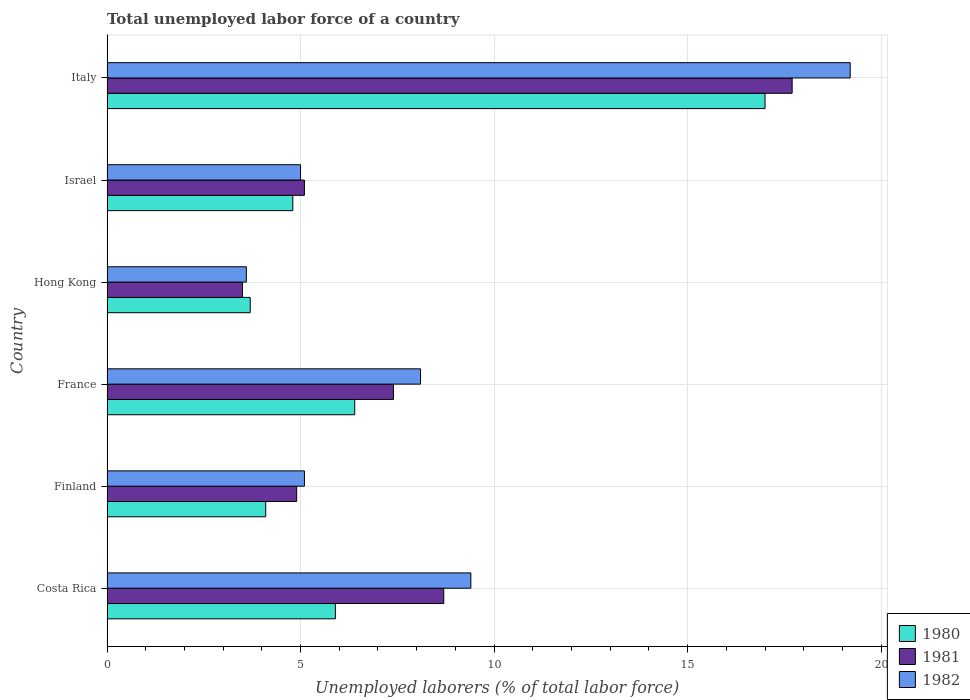How many different coloured bars are there?
Ensure brevity in your answer.  3. How many groups of bars are there?
Keep it short and to the point. 6. Are the number of bars per tick equal to the number of legend labels?
Your answer should be very brief. Yes. Are the number of bars on each tick of the Y-axis equal?
Keep it short and to the point. Yes. How many bars are there on the 4th tick from the top?
Offer a terse response. 3. How many bars are there on the 1st tick from the bottom?
Offer a very short reply. 3. What is the label of the 5th group of bars from the top?
Make the answer very short. Finland. In how many cases, is the number of bars for a given country not equal to the number of legend labels?
Make the answer very short. 0. What is the total unemployed labor force in 1981 in France?
Ensure brevity in your answer.  7.4. Across all countries, what is the maximum total unemployed labor force in 1980?
Your answer should be compact. 17. Across all countries, what is the minimum total unemployed labor force in 1981?
Your response must be concise. 3.5. In which country was the total unemployed labor force in 1980 maximum?
Give a very brief answer. Italy. In which country was the total unemployed labor force in 1982 minimum?
Provide a succinct answer. Hong Kong. What is the total total unemployed labor force in 1981 in the graph?
Ensure brevity in your answer.  47.3. What is the difference between the total unemployed labor force in 1982 in Hong Kong and that in Italy?
Provide a succinct answer. -15.6. What is the difference between the total unemployed labor force in 1981 in Italy and the total unemployed labor force in 1982 in Hong Kong?
Offer a very short reply. 14.1. What is the average total unemployed labor force in 1982 per country?
Give a very brief answer. 8.4. What is the difference between the total unemployed labor force in 1980 and total unemployed labor force in 1982 in Italy?
Ensure brevity in your answer.  -2.2. What is the ratio of the total unemployed labor force in 1980 in France to that in Hong Kong?
Give a very brief answer. 1.73. What is the difference between the highest and the second highest total unemployed labor force in 1980?
Provide a succinct answer. 10.6. What is the difference between the highest and the lowest total unemployed labor force in 1981?
Your answer should be very brief. 14.2. How many bars are there?
Make the answer very short. 18. Are all the bars in the graph horizontal?
Ensure brevity in your answer.  Yes. Does the graph contain grids?
Offer a terse response. Yes. How many legend labels are there?
Keep it short and to the point. 3. What is the title of the graph?
Give a very brief answer. Total unemployed labor force of a country. What is the label or title of the X-axis?
Your answer should be very brief. Unemployed laborers (% of total labor force). What is the label or title of the Y-axis?
Your response must be concise. Country. What is the Unemployed laborers (% of total labor force) in 1980 in Costa Rica?
Make the answer very short. 5.9. What is the Unemployed laborers (% of total labor force) of 1981 in Costa Rica?
Your answer should be compact. 8.7. What is the Unemployed laborers (% of total labor force) of 1982 in Costa Rica?
Offer a very short reply. 9.4. What is the Unemployed laborers (% of total labor force) of 1980 in Finland?
Provide a succinct answer. 4.1. What is the Unemployed laborers (% of total labor force) of 1981 in Finland?
Make the answer very short. 4.9. What is the Unemployed laborers (% of total labor force) of 1982 in Finland?
Ensure brevity in your answer.  5.1. What is the Unemployed laborers (% of total labor force) in 1980 in France?
Ensure brevity in your answer.  6.4. What is the Unemployed laborers (% of total labor force) of 1981 in France?
Your response must be concise. 7.4. What is the Unemployed laborers (% of total labor force) in 1982 in France?
Provide a succinct answer. 8.1. What is the Unemployed laborers (% of total labor force) in 1980 in Hong Kong?
Provide a short and direct response. 3.7. What is the Unemployed laborers (% of total labor force) of 1981 in Hong Kong?
Provide a short and direct response. 3.5. What is the Unemployed laborers (% of total labor force) of 1982 in Hong Kong?
Provide a succinct answer. 3.6. What is the Unemployed laborers (% of total labor force) in 1980 in Israel?
Your answer should be very brief. 4.8. What is the Unemployed laborers (% of total labor force) in 1981 in Israel?
Your response must be concise. 5.1. What is the Unemployed laborers (% of total labor force) in 1980 in Italy?
Your response must be concise. 17. What is the Unemployed laborers (% of total labor force) of 1981 in Italy?
Make the answer very short. 17.7. What is the Unemployed laborers (% of total labor force) in 1982 in Italy?
Provide a short and direct response. 19.2. Across all countries, what is the maximum Unemployed laborers (% of total labor force) in 1980?
Keep it short and to the point. 17. Across all countries, what is the maximum Unemployed laborers (% of total labor force) of 1981?
Give a very brief answer. 17.7. Across all countries, what is the maximum Unemployed laborers (% of total labor force) of 1982?
Your answer should be compact. 19.2. Across all countries, what is the minimum Unemployed laborers (% of total labor force) in 1980?
Keep it short and to the point. 3.7. Across all countries, what is the minimum Unemployed laborers (% of total labor force) of 1981?
Keep it short and to the point. 3.5. Across all countries, what is the minimum Unemployed laborers (% of total labor force) in 1982?
Provide a short and direct response. 3.6. What is the total Unemployed laborers (% of total labor force) of 1980 in the graph?
Your answer should be compact. 41.9. What is the total Unemployed laborers (% of total labor force) in 1981 in the graph?
Offer a very short reply. 47.3. What is the total Unemployed laborers (% of total labor force) in 1982 in the graph?
Keep it short and to the point. 50.4. What is the difference between the Unemployed laborers (% of total labor force) of 1982 in Costa Rica and that in Finland?
Offer a terse response. 4.3. What is the difference between the Unemployed laborers (% of total labor force) of 1980 in Costa Rica and that in Hong Kong?
Provide a short and direct response. 2.2. What is the difference between the Unemployed laborers (% of total labor force) in 1982 in Costa Rica and that in Hong Kong?
Offer a very short reply. 5.8. What is the difference between the Unemployed laborers (% of total labor force) in 1982 in Costa Rica and that in Israel?
Offer a terse response. 4.4. What is the difference between the Unemployed laborers (% of total labor force) of 1980 in Costa Rica and that in Italy?
Give a very brief answer. -11.1. What is the difference between the Unemployed laborers (% of total labor force) of 1982 in Costa Rica and that in Italy?
Give a very brief answer. -9.8. What is the difference between the Unemployed laborers (% of total labor force) in 1980 in Finland and that in France?
Give a very brief answer. -2.3. What is the difference between the Unemployed laborers (% of total labor force) of 1981 in Finland and that in France?
Offer a very short reply. -2.5. What is the difference between the Unemployed laborers (% of total labor force) of 1982 in Finland and that in France?
Give a very brief answer. -3. What is the difference between the Unemployed laborers (% of total labor force) in 1982 in Finland and that in Hong Kong?
Offer a very short reply. 1.5. What is the difference between the Unemployed laborers (% of total labor force) in 1981 in Finland and that in Israel?
Your answer should be very brief. -0.2. What is the difference between the Unemployed laborers (% of total labor force) of 1982 in Finland and that in Israel?
Your response must be concise. 0.1. What is the difference between the Unemployed laborers (% of total labor force) of 1980 in Finland and that in Italy?
Offer a terse response. -12.9. What is the difference between the Unemployed laborers (% of total labor force) of 1982 in Finland and that in Italy?
Ensure brevity in your answer.  -14.1. What is the difference between the Unemployed laborers (% of total labor force) in 1980 in France and that in Hong Kong?
Your answer should be very brief. 2.7. What is the difference between the Unemployed laborers (% of total labor force) of 1981 in France and that in Hong Kong?
Offer a very short reply. 3.9. What is the difference between the Unemployed laborers (% of total labor force) of 1982 in France and that in Hong Kong?
Provide a succinct answer. 4.5. What is the difference between the Unemployed laborers (% of total labor force) in 1981 in France and that in Israel?
Give a very brief answer. 2.3. What is the difference between the Unemployed laborers (% of total labor force) in 1980 in France and that in Italy?
Provide a succinct answer. -10.6. What is the difference between the Unemployed laborers (% of total labor force) in 1981 in France and that in Italy?
Your response must be concise. -10.3. What is the difference between the Unemployed laborers (% of total labor force) of 1981 in Hong Kong and that in Israel?
Provide a short and direct response. -1.6. What is the difference between the Unemployed laborers (% of total labor force) of 1981 in Hong Kong and that in Italy?
Give a very brief answer. -14.2. What is the difference between the Unemployed laborers (% of total labor force) in 1982 in Hong Kong and that in Italy?
Make the answer very short. -15.6. What is the difference between the Unemployed laborers (% of total labor force) in 1980 in Costa Rica and the Unemployed laborers (% of total labor force) in 1982 in Finland?
Provide a succinct answer. 0.8. What is the difference between the Unemployed laborers (% of total labor force) of 1980 in Costa Rica and the Unemployed laborers (% of total labor force) of 1981 in France?
Provide a short and direct response. -1.5. What is the difference between the Unemployed laborers (% of total labor force) in 1980 in Costa Rica and the Unemployed laborers (% of total labor force) in 1982 in France?
Your answer should be very brief. -2.2. What is the difference between the Unemployed laborers (% of total labor force) of 1980 in Costa Rica and the Unemployed laborers (% of total labor force) of 1981 in Hong Kong?
Keep it short and to the point. 2.4. What is the difference between the Unemployed laborers (% of total labor force) in 1981 in Costa Rica and the Unemployed laborers (% of total labor force) in 1982 in Hong Kong?
Provide a succinct answer. 5.1. What is the difference between the Unemployed laborers (% of total labor force) of 1980 in Costa Rica and the Unemployed laborers (% of total labor force) of 1981 in Israel?
Keep it short and to the point. 0.8. What is the difference between the Unemployed laborers (% of total labor force) in 1980 in Costa Rica and the Unemployed laborers (% of total labor force) in 1982 in Israel?
Provide a succinct answer. 0.9. What is the difference between the Unemployed laborers (% of total labor force) in 1981 in Costa Rica and the Unemployed laborers (% of total labor force) in 1982 in Israel?
Make the answer very short. 3.7. What is the difference between the Unemployed laborers (% of total labor force) in 1980 in Finland and the Unemployed laborers (% of total labor force) in 1981 in France?
Give a very brief answer. -3.3. What is the difference between the Unemployed laborers (% of total labor force) of 1980 in Finland and the Unemployed laborers (% of total labor force) of 1982 in France?
Keep it short and to the point. -4. What is the difference between the Unemployed laborers (% of total labor force) of 1980 in Finland and the Unemployed laborers (% of total labor force) of 1982 in Hong Kong?
Your response must be concise. 0.5. What is the difference between the Unemployed laborers (% of total labor force) of 1980 in Finland and the Unemployed laborers (% of total labor force) of 1982 in Israel?
Your answer should be very brief. -0.9. What is the difference between the Unemployed laborers (% of total labor force) of 1981 in Finland and the Unemployed laborers (% of total labor force) of 1982 in Israel?
Ensure brevity in your answer.  -0.1. What is the difference between the Unemployed laborers (% of total labor force) of 1980 in Finland and the Unemployed laborers (% of total labor force) of 1981 in Italy?
Ensure brevity in your answer.  -13.6. What is the difference between the Unemployed laborers (% of total labor force) of 1980 in Finland and the Unemployed laborers (% of total labor force) of 1982 in Italy?
Ensure brevity in your answer.  -15.1. What is the difference between the Unemployed laborers (% of total labor force) of 1981 in Finland and the Unemployed laborers (% of total labor force) of 1982 in Italy?
Your answer should be very brief. -14.3. What is the difference between the Unemployed laborers (% of total labor force) of 1980 in France and the Unemployed laborers (% of total labor force) of 1981 in Hong Kong?
Your response must be concise. 2.9. What is the difference between the Unemployed laborers (% of total labor force) in 1981 in France and the Unemployed laborers (% of total labor force) in 1982 in Hong Kong?
Keep it short and to the point. 3.8. What is the difference between the Unemployed laborers (% of total labor force) of 1980 in France and the Unemployed laborers (% of total labor force) of 1982 in Israel?
Ensure brevity in your answer.  1.4. What is the difference between the Unemployed laborers (% of total labor force) of 1981 in France and the Unemployed laborers (% of total labor force) of 1982 in Israel?
Offer a very short reply. 2.4. What is the difference between the Unemployed laborers (% of total labor force) in 1980 in France and the Unemployed laborers (% of total labor force) in 1981 in Italy?
Your response must be concise. -11.3. What is the difference between the Unemployed laborers (% of total labor force) of 1981 in France and the Unemployed laborers (% of total labor force) of 1982 in Italy?
Provide a short and direct response. -11.8. What is the difference between the Unemployed laborers (% of total labor force) in 1980 in Hong Kong and the Unemployed laborers (% of total labor force) in 1981 in Israel?
Make the answer very short. -1.4. What is the difference between the Unemployed laborers (% of total labor force) of 1980 in Hong Kong and the Unemployed laborers (% of total labor force) of 1982 in Israel?
Give a very brief answer. -1.3. What is the difference between the Unemployed laborers (% of total labor force) in 1980 in Hong Kong and the Unemployed laborers (% of total labor force) in 1982 in Italy?
Offer a very short reply. -15.5. What is the difference between the Unemployed laborers (% of total labor force) of 1981 in Hong Kong and the Unemployed laborers (% of total labor force) of 1982 in Italy?
Give a very brief answer. -15.7. What is the difference between the Unemployed laborers (% of total labor force) of 1980 in Israel and the Unemployed laborers (% of total labor force) of 1982 in Italy?
Offer a terse response. -14.4. What is the difference between the Unemployed laborers (% of total labor force) of 1981 in Israel and the Unemployed laborers (% of total labor force) of 1982 in Italy?
Your answer should be very brief. -14.1. What is the average Unemployed laborers (% of total labor force) of 1980 per country?
Your answer should be compact. 6.98. What is the average Unemployed laborers (% of total labor force) of 1981 per country?
Offer a terse response. 7.88. What is the average Unemployed laborers (% of total labor force) in 1982 per country?
Offer a terse response. 8.4. What is the difference between the Unemployed laborers (% of total labor force) in 1980 and Unemployed laborers (% of total labor force) in 1981 in Costa Rica?
Make the answer very short. -2.8. What is the difference between the Unemployed laborers (% of total labor force) in 1980 and Unemployed laborers (% of total labor force) in 1982 in Costa Rica?
Your response must be concise. -3.5. What is the difference between the Unemployed laborers (% of total labor force) in 1980 and Unemployed laborers (% of total labor force) in 1982 in Finland?
Offer a terse response. -1. What is the difference between the Unemployed laborers (% of total labor force) in 1981 and Unemployed laborers (% of total labor force) in 1982 in Finland?
Offer a terse response. -0.2. What is the difference between the Unemployed laborers (% of total labor force) of 1980 and Unemployed laborers (% of total labor force) of 1982 in France?
Ensure brevity in your answer.  -1.7. What is the difference between the Unemployed laborers (% of total labor force) in 1981 and Unemployed laborers (% of total labor force) in 1982 in France?
Your response must be concise. -0.7. What is the difference between the Unemployed laborers (% of total labor force) of 1980 and Unemployed laborers (% of total labor force) of 1981 in Hong Kong?
Give a very brief answer. 0.2. What is the difference between the Unemployed laborers (% of total labor force) of 1981 and Unemployed laborers (% of total labor force) of 1982 in Hong Kong?
Make the answer very short. -0.1. What is the difference between the Unemployed laborers (% of total labor force) in 1980 and Unemployed laborers (% of total labor force) in 1981 in Israel?
Your response must be concise. -0.3. What is the difference between the Unemployed laborers (% of total labor force) in 1981 and Unemployed laborers (% of total labor force) in 1982 in Italy?
Give a very brief answer. -1.5. What is the ratio of the Unemployed laborers (% of total labor force) in 1980 in Costa Rica to that in Finland?
Give a very brief answer. 1.44. What is the ratio of the Unemployed laborers (% of total labor force) of 1981 in Costa Rica to that in Finland?
Provide a succinct answer. 1.78. What is the ratio of the Unemployed laborers (% of total labor force) in 1982 in Costa Rica to that in Finland?
Offer a terse response. 1.84. What is the ratio of the Unemployed laborers (% of total labor force) in 1980 in Costa Rica to that in France?
Your response must be concise. 0.92. What is the ratio of the Unemployed laborers (% of total labor force) in 1981 in Costa Rica to that in France?
Your response must be concise. 1.18. What is the ratio of the Unemployed laborers (% of total labor force) of 1982 in Costa Rica to that in France?
Keep it short and to the point. 1.16. What is the ratio of the Unemployed laborers (% of total labor force) in 1980 in Costa Rica to that in Hong Kong?
Make the answer very short. 1.59. What is the ratio of the Unemployed laborers (% of total labor force) of 1981 in Costa Rica to that in Hong Kong?
Your response must be concise. 2.49. What is the ratio of the Unemployed laborers (% of total labor force) in 1982 in Costa Rica to that in Hong Kong?
Make the answer very short. 2.61. What is the ratio of the Unemployed laborers (% of total labor force) of 1980 in Costa Rica to that in Israel?
Provide a short and direct response. 1.23. What is the ratio of the Unemployed laborers (% of total labor force) of 1981 in Costa Rica to that in Israel?
Make the answer very short. 1.71. What is the ratio of the Unemployed laborers (% of total labor force) of 1982 in Costa Rica to that in Israel?
Keep it short and to the point. 1.88. What is the ratio of the Unemployed laborers (% of total labor force) of 1980 in Costa Rica to that in Italy?
Make the answer very short. 0.35. What is the ratio of the Unemployed laborers (% of total labor force) of 1981 in Costa Rica to that in Italy?
Your answer should be very brief. 0.49. What is the ratio of the Unemployed laborers (% of total labor force) in 1982 in Costa Rica to that in Italy?
Your response must be concise. 0.49. What is the ratio of the Unemployed laborers (% of total labor force) of 1980 in Finland to that in France?
Offer a terse response. 0.64. What is the ratio of the Unemployed laborers (% of total labor force) in 1981 in Finland to that in France?
Your response must be concise. 0.66. What is the ratio of the Unemployed laborers (% of total labor force) in 1982 in Finland to that in France?
Your answer should be compact. 0.63. What is the ratio of the Unemployed laborers (% of total labor force) in 1980 in Finland to that in Hong Kong?
Offer a very short reply. 1.11. What is the ratio of the Unemployed laborers (% of total labor force) of 1982 in Finland to that in Hong Kong?
Offer a terse response. 1.42. What is the ratio of the Unemployed laborers (% of total labor force) in 1980 in Finland to that in Israel?
Make the answer very short. 0.85. What is the ratio of the Unemployed laborers (% of total labor force) of 1981 in Finland to that in Israel?
Keep it short and to the point. 0.96. What is the ratio of the Unemployed laborers (% of total labor force) in 1982 in Finland to that in Israel?
Your answer should be very brief. 1.02. What is the ratio of the Unemployed laborers (% of total labor force) in 1980 in Finland to that in Italy?
Give a very brief answer. 0.24. What is the ratio of the Unemployed laborers (% of total labor force) in 1981 in Finland to that in Italy?
Offer a very short reply. 0.28. What is the ratio of the Unemployed laborers (% of total labor force) in 1982 in Finland to that in Italy?
Provide a succinct answer. 0.27. What is the ratio of the Unemployed laborers (% of total labor force) in 1980 in France to that in Hong Kong?
Make the answer very short. 1.73. What is the ratio of the Unemployed laborers (% of total labor force) in 1981 in France to that in Hong Kong?
Keep it short and to the point. 2.11. What is the ratio of the Unemployed laborers (% of total labor force) in 1982 in France to that in Hong Kong?
Your response must be concise. 2.25. What is the ratio of the Unemployed laborers (% of total labor force) of 1981 in France to that in Israel?
Keep it short and to the point. 1.45. What is the ratio of the Unemployed laborers (% of total labor force) of 1982 in France to that in Israel?
Provide a succinct answer. 1.62. What is the ratio of the Unemployed laborers (% of total labor force) of 1980 in France to that in Italy?
Give a very brief answer. 0.38. What is the ratio of the Unemployed laborers (% of total labor force) of 1981 in France to that in Italy?
Your response must be concise. 0.42. What is the ratio of the Unemployed laborers (% of total labor force) of 1982 in France to that in Italy?
Provide a short and direct response. 0.42. What is the ratio of the Unemployed laborers (% of total labor force) of 1980 in Hong Kong to that in Israel?
Your response must be concise. 0.77. What is the ratio of the Unemployed laborers (% of total labor force) in 1981 in Hong Kong to that in Israel?
Your response must be concise. 0.69. What is the ratio of the Unemployed laborers (% of total labor force) of 1982 in Hong Kong to that in Israel?
Provide a succinct answer. 0.72. What is the ratio of the Unemployed laborers (% of total labor force) in 1980 in Hong Kong to that in Italy?
Give a very brief answer. 0.22. What is the ratio of the Unemployed laborers (% of total labor force) in 1981 in Hong Kong to that in Italy?
Your answer should be very brief. 0.2. What is the ratio of the Unemployed laborers (% of total labor force) in 1982 in Hong Kong to that in Italy?
Keep it short and to the point. 0.19. What is the ratio of the Unemployed laborers (% of total labor force) in 1980 in Israel to that in Italy?
Provide a succinct answer. 0.28. What is the ratio of the Unemployed laborers (% of total labor force) of 1981 in Israel to that in Italy?
Your answer should be very brief. 0.29. What is the ratio of the Unemployed laborers (% of total labor force) of 1982 in Israel to that in Italy?
Give a very brief answer. 0.26. What is the difference between the highest and the second highest Unemployed laborers (% of total labor force) in 1980?
Provide a succinct answer. 10.6. What is the difference between the highest and the second highest Unemployed laborers (% of total labor force) in 1981?
Offer a terse response. 9. What is the difference between the highest and the second highest Unemployed laborers (% of total labor force) of 1982?
Ensure brevity in your answer.  9.8. What is the difference between the highest and the lowest Unemployed laborers (% of total labor force) of 1980?
Offer a very short reply. 13.3. What is the difference between the highest and the lowest Unemployed laborers (% of total labor force) of 1981?
Provide a short and direct response. 14.2. What is the difference between the highest and the lowest Unemployed laborers (% of total labor force) in 1982?
Your answer should be very brief. 15.6. 